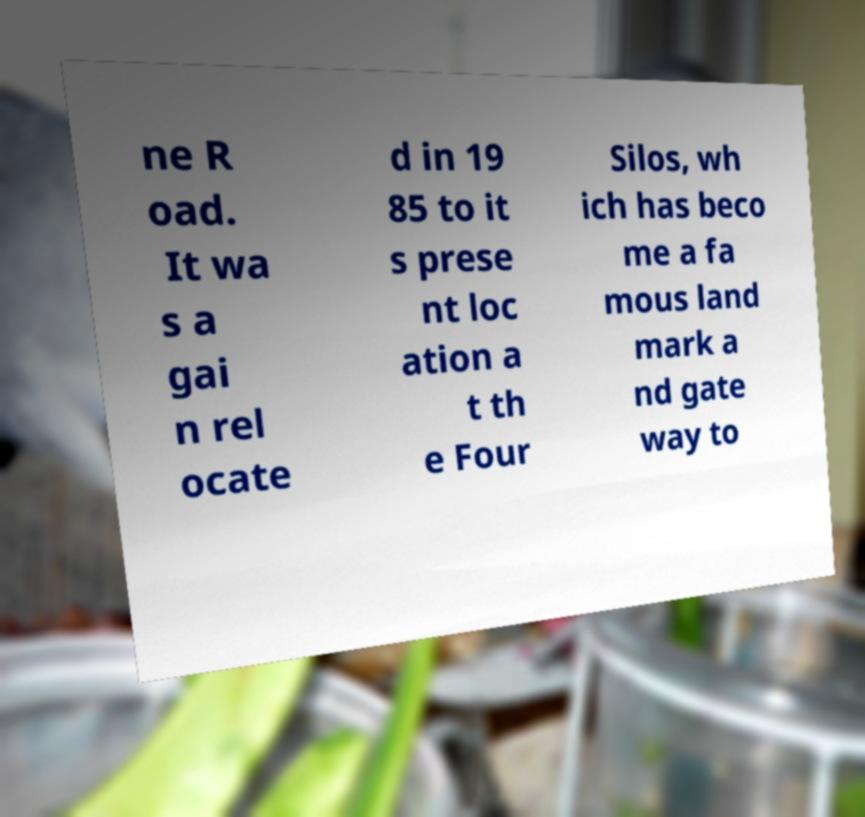Can you accurately transcribe the text from the provided image for me? ne R oad. It wa s a gai n rel ocate d in 19 85 to it s prese nt loc ation a t th e Four Silos, wh ich has beco me a fa mous land mark a nd gate way to 